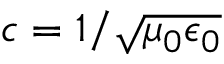Convert formula to latex. <formula><loc_0><loc_0><loc_500><loc_500>c = 1 / \sqrt { \mu _ { 0 } \epsilon _ { 0 } }</formula> 